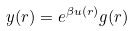Convert formula to latex. <formula><loc_0><loc_0><loc_500><loc_500>y ( r ) = e ^ { \beta u ( r ) } g ( r )</formula> 